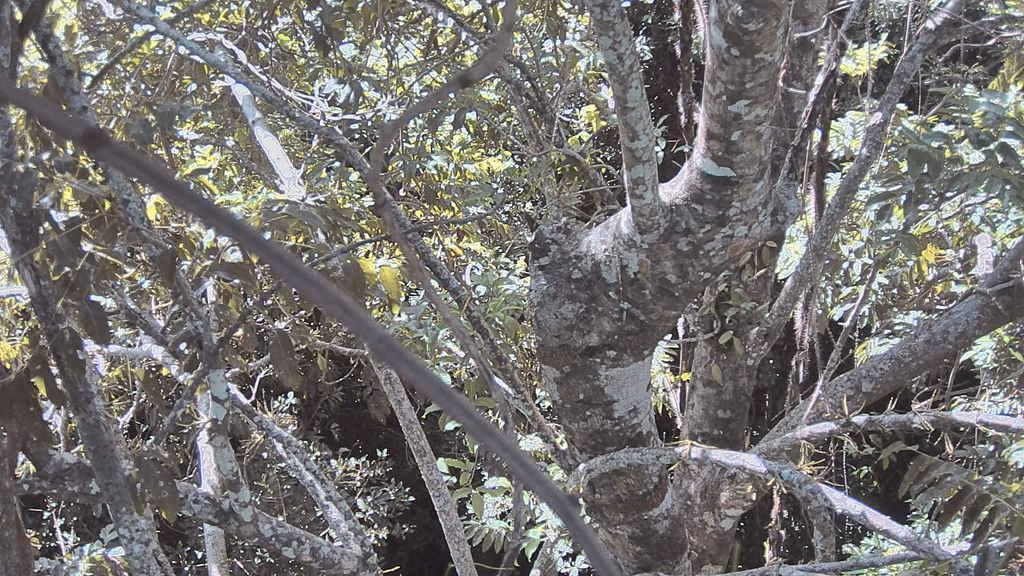What type of vegetation can be seen in the image? There are trees in the image. Where are the tree branches located in the image? Tree branches are visible on the left side of the image. What can be seen in the background of the image? Many leaves are present in the background of the image. What type of tool is being used by the toad in the image? There is no toad or tool present in the image. 